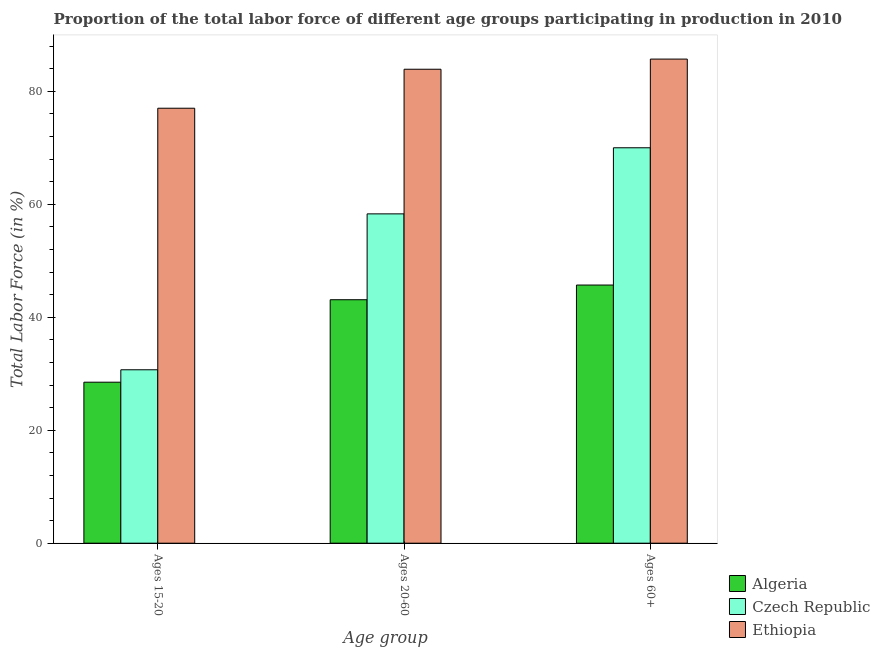What is the label of the 1st group of bars from the left?
Ensure brevity in your answer.  Ages 15-20. Across all countries, what is the maximum percentage of labor force within the age group 20-60?
Your response must be concise. 83.9. Across all countries, what is the minimum percentage of labor force within the age group 15-20?
Provide a short and direct response. 28.5. In which country was the percentage of labor force within the age group 15-20 maximum?
Provide a short and direct response. Ethiopia. In which country was the percentage of labor force above age 60 minimum?
Your answer should be very brief. Algeria. What is the total percentage of labor force within the age group 20-60 in the graph?
Your response must be concise. 185.3. What is the difference between the percentage of labor force within the age group 20-60 in Algeria and that in Czech Republic?
Provide a succinct answer. -15.2. What is the difference between the percentage of labor force within the age group 15-20 in Algeria and the percentage of labor force within the age group 20-60 in Czech Republic?
Offer a very short reply. -29.8. What is the average percentage of labor force above age 60 per country?
Make the answer very short. 67.13. What is the difference between the percentage of labor force within the age group 20-60 and percentage of labor force above age 60 in Czech Republic?
Ensure brevity in your answer.  -11.7. In how many countries, is the percentage of labor force within the age group 20-60 greater than 32 %?
Offer a very short reply. 3. What is the ratio of the percentage of labor force above age 60 in Czech Republic to that in Ethiopia?
Provide a short and direct response. 0.82. Is the percentage of labor force within the age group 20-60 in Czech Republic less than that in Algeria?
Your answer should be compact. No. What is the difference between the highest and the second highest percentage of labor force within the age group 20-60?
Offer a terse response. 25.6. What is the difference between the highest and the lowest percentage of labor force within the age group 15-20?
Offer a very short reply. 48.5. What does the 2nd bar from the left in Ages 60+ represents?
Give a very brief answer. Czech Republic. What does the 3rd bar from the right in Ages 60+ represents?
Your answer should be compact. Algeria. How many countries are there in the graph?
Ensure brevity in your answer.  3. What is the difference between two consecutive major ticks on the Y-axis?
Offer a terse response. 20. Are the values on the major ticks of Y-axis written in scientific E-notation?
Give a very brief answer. No. Does the graph contain any zero values?
Your response must be concise. No. Does the graph contain grids?
Ensure brevity in your answer.  No. How many legend labels are there?
Ensure brevity in your answer.  3. What is the title of the graph?
Your response must be concise. Proportion of the total labor force of different age groups participating in production in 2010. Does "Maldives" appear as one of the legend labels in the graph?
Make the answer very short. No. What is the label or title of the X-axis?
Provide a succinct answer. Age group. What is the label or title of the Y-axis?
Ensure brevity in your answer.  Total Labor Force (in %). What is the Total Labor Force (in %) of Algeria in Ages 15-20?
Give a very brief answer. 28.5. What is the Total Labor Force (in %) of Czech Republic in Ages 15-20?
Your answer should be very brief. 30.7. What is the Total Labor Force (in %) of Ethiopia in Ages 15-20?
Provide a succinct answer. 77. What is the Total Labor Force (in %) in Algeria in Ages 20-60?
Provide a succinct answer. 43.1. What is the Total Labor Force (in %) in Czech Republic in Ages 20-60?
Ensure brevity in your answer.  58.3. What is the Total Labor Force (in %) of Ethiopia in Ages 20-60?
Offer a terse response. 83.9. What is the Total Labor Force (in %) in Algeria in Ages 60+?
Ensure brevity in your answer.  45.7. What is the Total Labor Force (in %) in Czech Republic in Ages 60+?
Make the answer very short. 70. What is the Total Labor Force (in %) in Ethiopia in Ages 60+?
Your response must be concise. 85.7. Across all Age group, what is the maximum Total Labor Force (in %) of Algeria?
Offer a terse response. 45.7. Across all Age group, what is the maximum Total Labor Force (in %) in Czech Republic?
Your response must be concise. 70. Across all Age group, what is the maximum Total Labor Force (in %) in Ethiopia?
Your answer should be compact. 85.7. Across all Age group, what is the minimum Total Labor Force (in %) in Algeria?
Keep it short and to the point. 28.5. Across all Age group, what is the minimum Total Labor Force (in %) of Czech Republic?
Provide a succinct answer. 30.7. What is the total Total Labor Force (in %) of Algeria in the graph?
Keep it short and to the point. 117.3. What is the total Total Labor Force (in %) of Czech Republic in the graph?
Make the answer very short. 159. What is the total Total Labor Force (in %) of Ethiopia in the graph?
Keep it short and to the point. 246.6. What is the difference between the Total Labor Force (in %) of Algeria in Ages 15-20 and that in Ages 20-60?
Provide a succinct answer. -14.6. What is the difference between the Total Labor Force (in %) in Czech Republic in Ages 15-20 and that in Ages 20-60?
Your answer should be very brief. -27.6. What is the difference between the Total Labor Force (in %) in Algeria in Ages 15-20 and that in Ages 60+?
Provide a short and direct response. -17.2. What is the difference between the Total Labor Force (in %) of Czech Republic in Ages 15-20 and that in Ages 60+?
Your answer should be compact. -39.3. What is the difference between the Total Labor Force (in %) of Algeria in Ages 15-20 and the Total Labor Force (in %) of Czech Republic in Ages 20-60?
Give a very brief answer. -29.8. What is the difference between the Total Labor Force (in %) of Algeria in Ages 15-20 and the Total Labor Force (in %) of Ethiopia in Ages 20-60?
Ensure brevity in your answer.  -55.4. What is the difference between the Total Labor Force (in %) in Czech Republic in Ages 15-20 and the Total Labor Force (in %) in Ethiopia in Ages 20-60?
Your answer should be very brief. -53.2. What is the difference between the Total Labor Force (in %) in Algeria in Ages 15-20 and the Total Labor Force (in %) in Czech Republic in Ages 60+?
Your response must be concise. -41.5. What is the difference between the Total Labor Force (in %) in Algeria in Ages 15-20 and the Total Labor Force (in %) in Ethiopia in Ages 60+?
Give a very brief answer. -57.2. What is the difference between the Total Labor Force (in %) in Czech Republic in Ages 15-20 and the Total Labor Force (in %) in Ethiopia in Ages 60+?
Ensure brevity in your answer.  -55. What is the difference between the Total Labor Force (in %) in Algeria in Ages 20-60 and the Total Labor Force (in %) in Czech Republic in Ages 60+?
Keep it short and to the point. -26.9. What is the difference between the Total Labor Force (in %) in Algeria in Ages 20-60 and the Total Labor Force (in %) in Ethiopia in Ages 60+?
Your response must be concise. -42.6. What is the difference between the Total Labor Force (in %) in Czech Republic in Ages 20-60 and the Total Labor Force (in %) in Ethiopia in Ages 60+?
Keep it short and to the point. -27.4. What is the average Total Labor Force (in %) of Algeria per Age group?
Keep it short and to the point. 39.1. What is the average Total Labor Force (in %) in Ethiopia per Age group?
Your answer should be compact. 82.2. What is the difference between the Total Labor Force (in %) of Algeria and Total Labor Force (in %) of Ethiopia in Ages 15-20?
Offer a terse response. -48.5. What is the difference between the Total Labor Force (in %) of Czech Republic and Total Labor Force (in %) of Ethiopia in Ages 15-20?
Offer a very short reply. -46.3. What is the difference between the Total Labor Force (in %) in Algeria and Total Labor Force (in %) in Czech Republic in Ages 20-60?
Your answer should be very brief. -15.2. What is the difference between the Total Labor Force (in %) in Algeria and Total Labor Force (in %) in Ethiopia in Ages 20-60?
Provide a succinct answer. -40.8. What is the difference between the Total Labor Force (in %) of Czech Republic and Total Labor Force (in %) of Ethiopia in Ages 20-60?
Your response must be concise. -25.6. What is the difference between the Total Labor Force (in %) of Algeria and Total Labor Force (in %) of Czech Republic in Ages 60+?
Offer a terse response. -24.3. What is the difference between the Total Labor Force (in %) of Czech Republic and Total Labor Force (in %) of Ethiopia in Ages 60+?
Your response must be concise. -15.7. What is the ratio of the Total Labor Force (in %) in Algeria in Ages 15-20 to that in Ages 20-60?
Give a very brief answer. 0.66. What is the ratio of the Total Labor Force (in %) of Czech Republic in Ages 15-20 to that in Ages 20-60?
Keep it short and to the point. 0.53. What is the ratio of the Total Labor Force (in %) in Ethiopia in Ages 15-20 to that in Ages 20-60?
Offer a terse response. 0.92. What is the ratio of the Total Labor Force (in %) in Algeria in Ages 15-20 to that in Ages 60+?
Offer a terse response. 0.62. What is the ratio of the Total Labor Force (in %) of Czech Republic in Ages 15-20 to that in Ages 60+?
Your response must be concise. 0.44. What is the ratio of the Total Labor Force (in %) in Ethiopia in Ages 15-20 to that in Ages 60+?
Offer a very short reply. 0.9. What is the ratio of the Total Labor Force (in %) in Algeria in Ages 20-60 to that in Ages 60+?
Your answer should be compact. 0.94. What is the ratio of the Total Labor Force (in %) of Czech Republic in Ages 20-60 to that in Ages 60+?
Make the answer very short. 0.83. What is the ratio of the Total Labor Force (in %) of Ethiopia in Ages 20-60 to that in Ages 60+?
Give a very brief answer. 0.98. What is the difference between the highest and the second highest Total Labor Force (in %) in Algeria?
Provide a short and direct response. 2.6. What is the difference between the highest and the second highest Total Labor Force (in %) of Czech Republic?
Ensure brevity in your answer.  11.7. What is the difference between the highest and the lowest Total Labor Force (in %) of Czech Republic?
Your answer should be very brief. 39.3. What is the difference between the highest and the lowest Total Labor Force (in %) in Ethiopia?
Your answer should be compact. 8.7. 